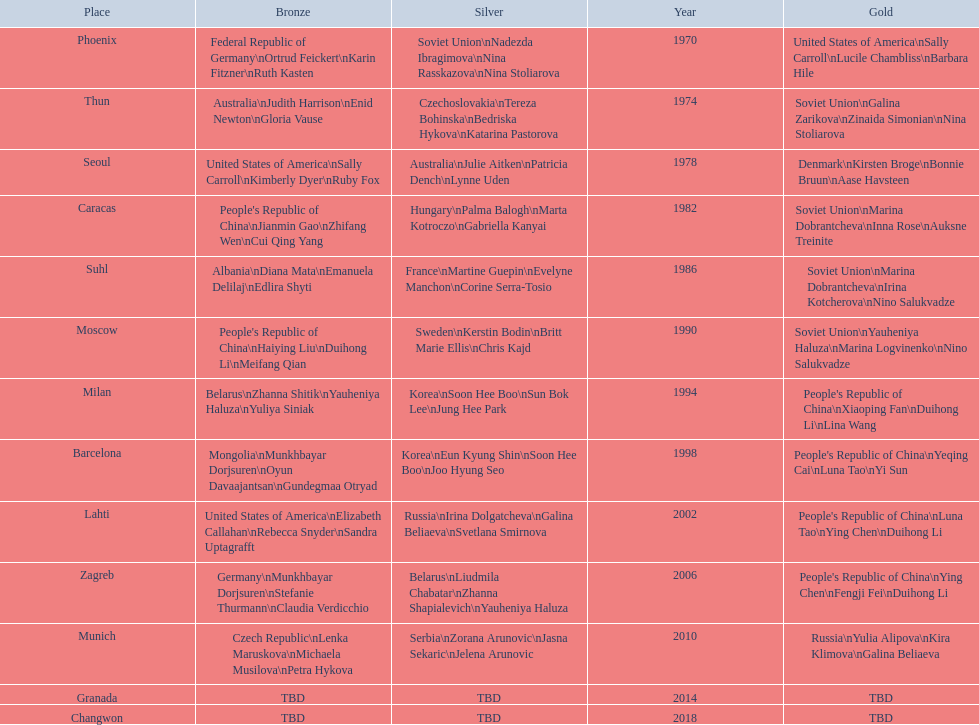How many world championships had the soviet union won first place in in the 25 metre pistol women's world championship? 4. 